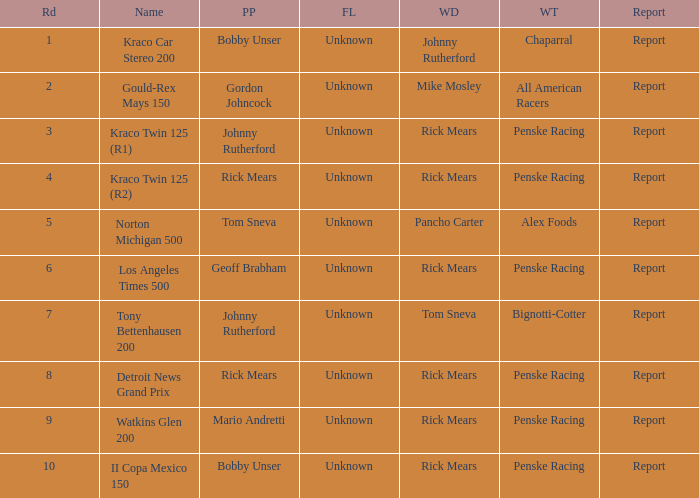Help me parse the entirety of this table. {'header': ['Rd', 'Name', 'PP', 'FL', 'WD', 'WT', 'Report'], 'rows': [['1', 'Kraco Car Stereo 200', 'Bobby Unser', 'Unknown', 'Johnny Rutherford', 'Chaparral', 'Report'], ['2', 'Gould-Rex Mays 150', 'Gordon Johncock', 'Unknown', 'Mike Mosley', 'All American Racers', 'Report'], ['3', 'Kraco Twin 125 (R1)', 'Johnny Rutherford', 'Unknown', 'Rick Mears', 'Penske Racing', 'Report'], ['4', 'Kraco Twin 125 (R2)', 'Rick Mears', 'Unknown', 'Rick Mears', 'Penske Racing', 'Report'], ['5', 'Norton Michigan 500', 'Tom Sneva', 'Unknown', 'Pancho Carter', 'Alex Foods', 'Report'], ['6', 'Los Angeles Times 500', 'Geoff Brabham', 'Unknown', 'Rick Mears', 'Penske Racing', 'Report'], ['7', 'Tony Bettenhausen 200', 'Johnny Rutherford', 'Unknown', 'Tom Sneva', 'Bignotti-Cotter', 'Report'], ['8', 'Detroit News Grand Prix', 'Rick Mears', 'Unknown', 'Rick Mears', 'Penske Racing', 'Report'], ['9', 'Watkins Glen 200', 'Mario Andretti', 'Unknown', 'Rick Mears', 'Penske Racing', 'Report'], ['10', 'II Copa Mexico 150', 'Bobby Unser', 'Unknown', 'Rick Mears', 'Penske Racing', 'Report']]} How many winning drivers in the kraco twin 125 (r2) race were there? 1.0. 